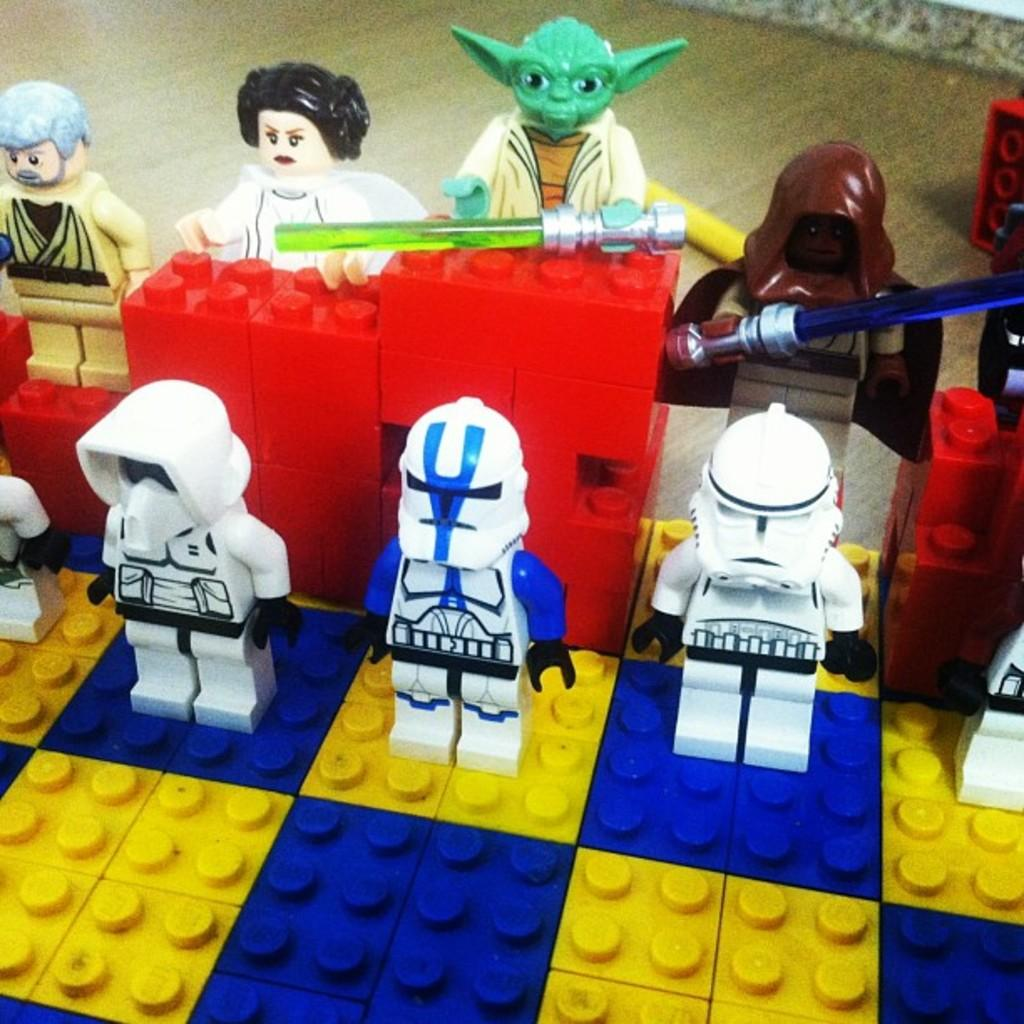What type of toys are visible in the image? There are LEGO toys in the image. What surface can be seen at the bottom of the image? The image appears to depict a floor at the bottom. What type of meal is being prepared in the image? There is no meal preparation visible in the image; it only features LEGO toys and a floor. 